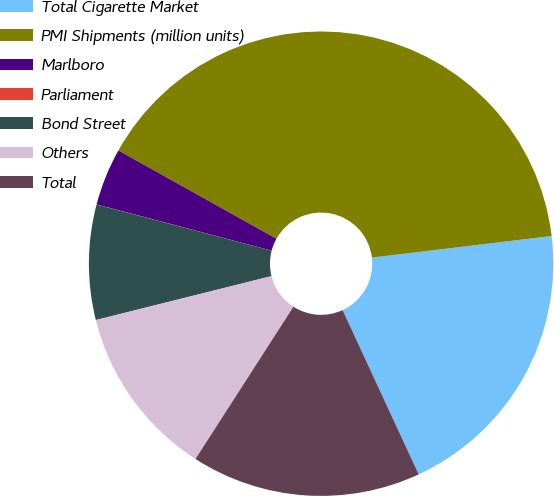Convert chart. <chart><loc_0><loc_0><loc_500><loc_500><pie_chart><fcel>Total Cigarette Market<fcel>PMI Shipments (million units)<fcel>Marlboro<fcel>Parliament<fcel>Bond Street<fcel>Others<fcel>Total<nl><fcel>20.0%<fcel>39.99%<fcel>4.0%<fcel>0.01%<fcel>8.0%<fcel>12.0%<fcel>16.0%<nl></chart> 